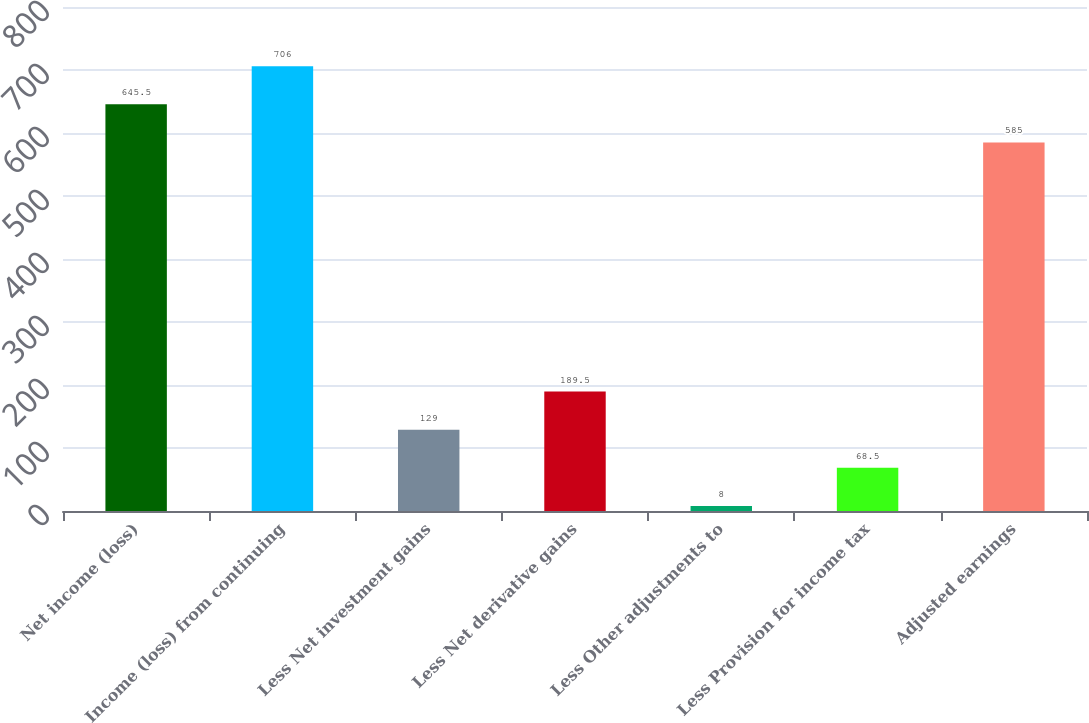Convert chart to OTSL. <chart><loc_0><loc_0><loc_500><loc_500><bar_chart><fcel>Net income (loss)<fcel>Income (loss) from continuing<fcel>Less Net investment gains<fcel>Less Net derivative gains<fcel>Less Other adjustments to<fcel>Less Provision for income tax<fcel>Adjusted earnings<nl><fcel>645.5<fcel>706<fcel>129<fcel>189.5<fcel>8<fcel>68.5<fcel>585<nl></chart> 